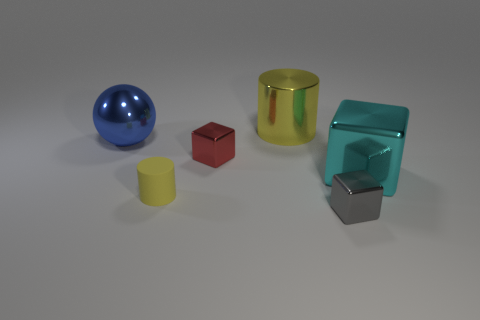Subtract all large shiny cubes. How many cubes are left? 2 Add 2 metallic blocks. How many objects exist? 8 Subtract all cylinders. How many objects are left? 4 Add 5 large cyan metal cubes. How many large cyan metal cubes are left? 6 Add 6 tiny rubber things. How many tiny rubber things exist? 7 Subtract 0 brown balls. How many objects are left? 6 Subtract all green spheres. Subtract all brown cubes. How many spheres are left? 1 Subtract all blue cubes. How many green cylinders are left? 0 Subtract all metal blocks. Subtract all small shiny blocks. How many objects are left? 1 